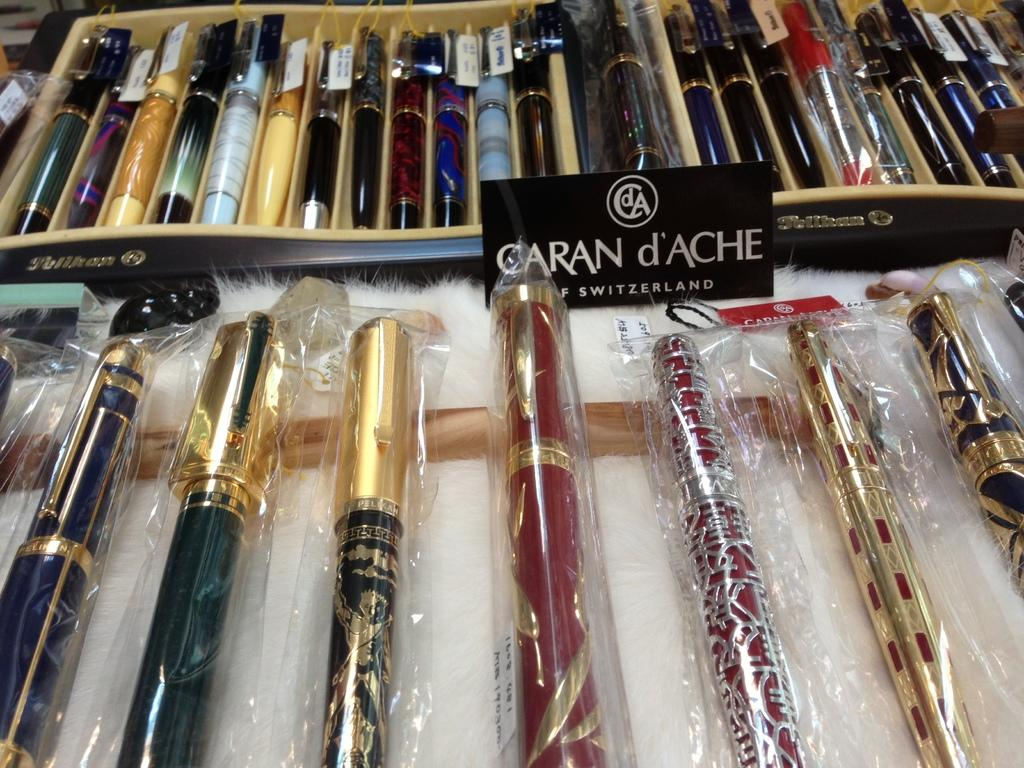What objects are visible in the image? There are pens in the image. Where are the pens located? The pens are on a table. What type of locket is hanging from the pens in the image? There is no locket present in the image; it only features pens on a table. 